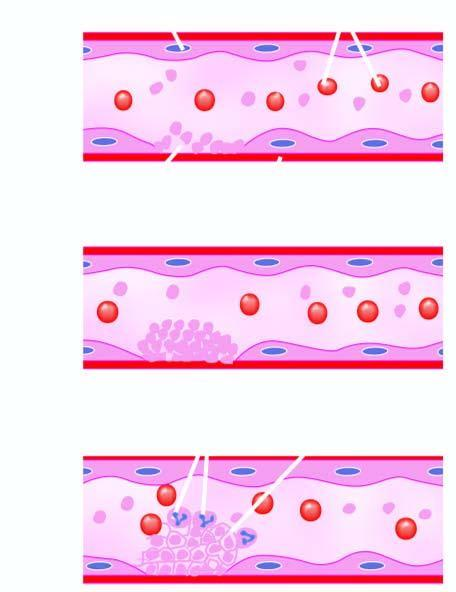does aemosiderin pigment in the cytoplasm of hepatocytes form fibrin strands in which are entangled some leucocytes and red cells and a tight meshwork is formed called thrombus?
Answer the question using a single word or phrase. No 